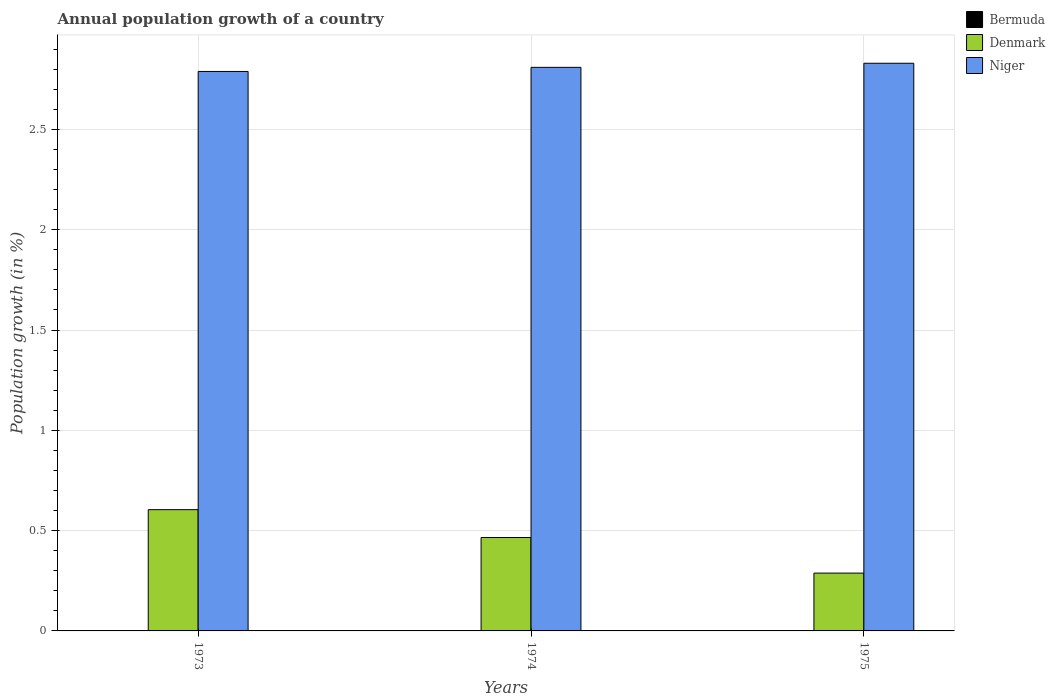How many different coloured bars are there?
Give a very brief answer. 2. Are the number of bars per tick equal to the number of legend labels?
Make the answer very short. No. How many bars are there on the 3rd tick from the left?
Provide a succinct answer. 2. How many bars are there on the 1st tick from the right?
Provide a succinct answer. 2. What is the label of the 3rd group of bars from the left?
Offer a terse response. 1975. In how many cases, is the number of bars for a given year not equal to the number of legend labels?
Provide a succinct answer. 3. What is the annual population growth in Denmark in 1973?
Keep it short and to the point. 0.6. Across all years, what is the maximum annual population growth in Denmark?
Make the answer very short. 0.6. Across all years, what is the minimum annual population growth in Denmark?
Offer a very short reply. 0.29. In which year was the annual population growth in Denmark maximum?
Offer a terse response. 1973. What is the difference between the annual population growth in Niger in 1973 and that in 1974?
Your response must be concise. -0.02. What is the difference between the annual population growth in Niger in 1973 and the annual population growth in Denmark in 1974?
Give a very brief answer. 2.32. What is the average annual population growth in Niger per year?
Offer a terse response. 2.81. In the year 1974, what is the difference between the annual population growth in Denmark and annual population growth in Niger?
Give a very brief answer. -2.34. What is the ratio of the annual population growth in Denmark in 1973 to that in 1974?
Your response must be concise. 1.3. Is the difference between the annual population growth in Denmark in 1974 and 1975 greater than the difference between the annual population growth in Niger in 1974 and 1975?
Offer a very short reply. Yes. What is the difference between the highest and the second highest annual population growth in Denmark?
Your answer should be compact. 0.14. What is the difference between the highest and the lowest annual population growth in Niger?
Your answer should be very brief. 0.04. In how many years, is the annual population growth in Denmark greater than the average annual population growth in Denmark taken over all years?
Your answer should be very brief. 2. Is it the case that in every year, the sum of the annual population growth in Bermuda and annual population growth in Denmark is greater than the annual population growth in Niger?
Provide a succinct answer. No. How many bars are there?
Offer a terse response. 6. Are all the bars in the graph horizontal?
Your response must be concise. No. Are the values on the major ticks of Y-axis written in scientific E-notation?
Keep it short and to the point. No. Does the graph contain any zero values?
Ensure brevity in your answer.  Yes. Does the graph contain grids?
Keep it short and to the point. Yes. Where does the legend appear in the graph?
Provide a short and direct response. Top right. How many legend labels are there?
Provide a succinct answer. 3. How are the legend labels stacked?
Ensure brevity in your answer.  Vertical. What is the title of the graph?
Your answer should be compact. Annual population growth of a country. What is the label or title of the Y-axis?
Your answer should be compact. Population growth (in %). What is the Population growth (in %) in Bermuda in 1973?
Keep it short and to the point. 0. What is the Population growth (in %) of Denmark in 1973?
Make the answer very short. 0.6. What is the Population growth (in %) in Niger in 1973?
Give a very brief answer. 2.79. What is the Population growth (in %) of Bermuda in 1974?
Ensure brevity in your answer.  0. What is the Population growth (in %) of Denmark in 1974?
Ensure brevity in your answer.  0.47. What is the Population growth (in %) in Niger in 1974?
Ensure brevity in your answer.  2.81. What is the Population growth (in %) in Denmark in 1975?
Provide a short and direct response. 0.29. What is the Population growth (in %) of Niger in 1975?
Provide a succinct answer. 2.83. Across all years, what is the maximum Population growth (in %) in Denmark?
Your response must be concise. 0.6. Across all years, what is the maximum Population growth (in %) of Niger?
Keep it short and to the point. 2.83. Across all years, what is the minimum Population growth (in %) in Denmark?
Offer a terse response. 0.29. Across all years, what is the minimum Population growth (in %) in Niger?
Your answer should be very brief. 2.79. What is the total Population growth (in %) in Denmark in the graph?
Offer a very short reply. 1.36. What is the total Population growth (in %) of Niger in the graph?
Your response must be concise. 8.43. What is the difference between the Population growth (in %) of Denmark in 1973 and that in 1974?
Offer a very short reply. 0.14. What is the difference between the Population growth (in %) in Niger in 1973 and that in 1974?
Keep it short and to the point. -0.02. What is the difference between the Population growth (in %) in Denmark in 1973 and that in 1975?
Give a very brief answer. 0.32. What is the difference between the Population growth (in %) in Niger in 1973 and that in 1975?
Your response must be concise. -0.04. What is the difference between the Population growth (in %) in Denmark in 1974 and that in 1975?
Provide a succinct answer. 0.18. What is the difference between the Population growth (in %) of Niger in 1974 and that in 1975?
Ensure brevity in your answer.  -0.02. What is the difference between the Population growth (in %) in Denmark in 1973 and the Population growth (in %) in Niger in 1974?
Give a very brief answer. -2.21. What is the difference between the Population growth (in %) in Denmark in 1973 and the Population growth (in %) in Niger in 1975?
Your answer should be compact. -2.23. What is the difference between the Population growth (in %) in Denmark in 1974 and the Population growth (in %) in Niger in 1975?
Your answer should be very brief. -2.36. What is the average Population growth (in %) of Denmark per year?
Your answer should be very brief. 0.45. What is the average Population growth (in %) of Niger per year?
Your response must be concise. 2.81. In the year 1973, what is the difference between the Population growth (in %) in Denmark and Population growth (in %) in Niger?
Your answer should be very brief. -2.18. In the year 1974, what is the difference between the Population growth (in %) in Denmark and Population growth (in %) in Niger?
Your answer should be compact. -2.34. In the year 1975, what is the difference between the Population growth (in %) in Denmark and Population growth (in %) in Niger?
Ensure brevity in your answer.  -2.54. What is the ratio of the Population growth (in %) in Denmark in 1973 to that in 1974?
Provide a short and direct response. 1.3. What is the ratio of the Population growth (in %) in Denmark in 1973 to that in 1975?
Keep it short and to the point. 2.1. What is the ratio of the Population growth (in %) of Niger in 1973 to that in 1975?
Your response must be concise. 0.99. What is the ratio of the Population growth (in %) of Denmark in 1974 to that in 1975?
Ensure brevity in your answer.  1.62. What is the difference between the highest and the second highest Population growth (in %) of Denmark?
Provide a short and direct response. 0.14. What is the difference between the highest and the second highest Population growth (in %) in Niger?
Ensure brevity in your answer.  0.02. What is the difference between the highest and the lowest Population growth (in %) of Denmark?
Your answer should be very brief. 0.32. What is the difference between the highest and the lowest Population growth (in %) in Niger?
Your answer should be compact. 0.04. 